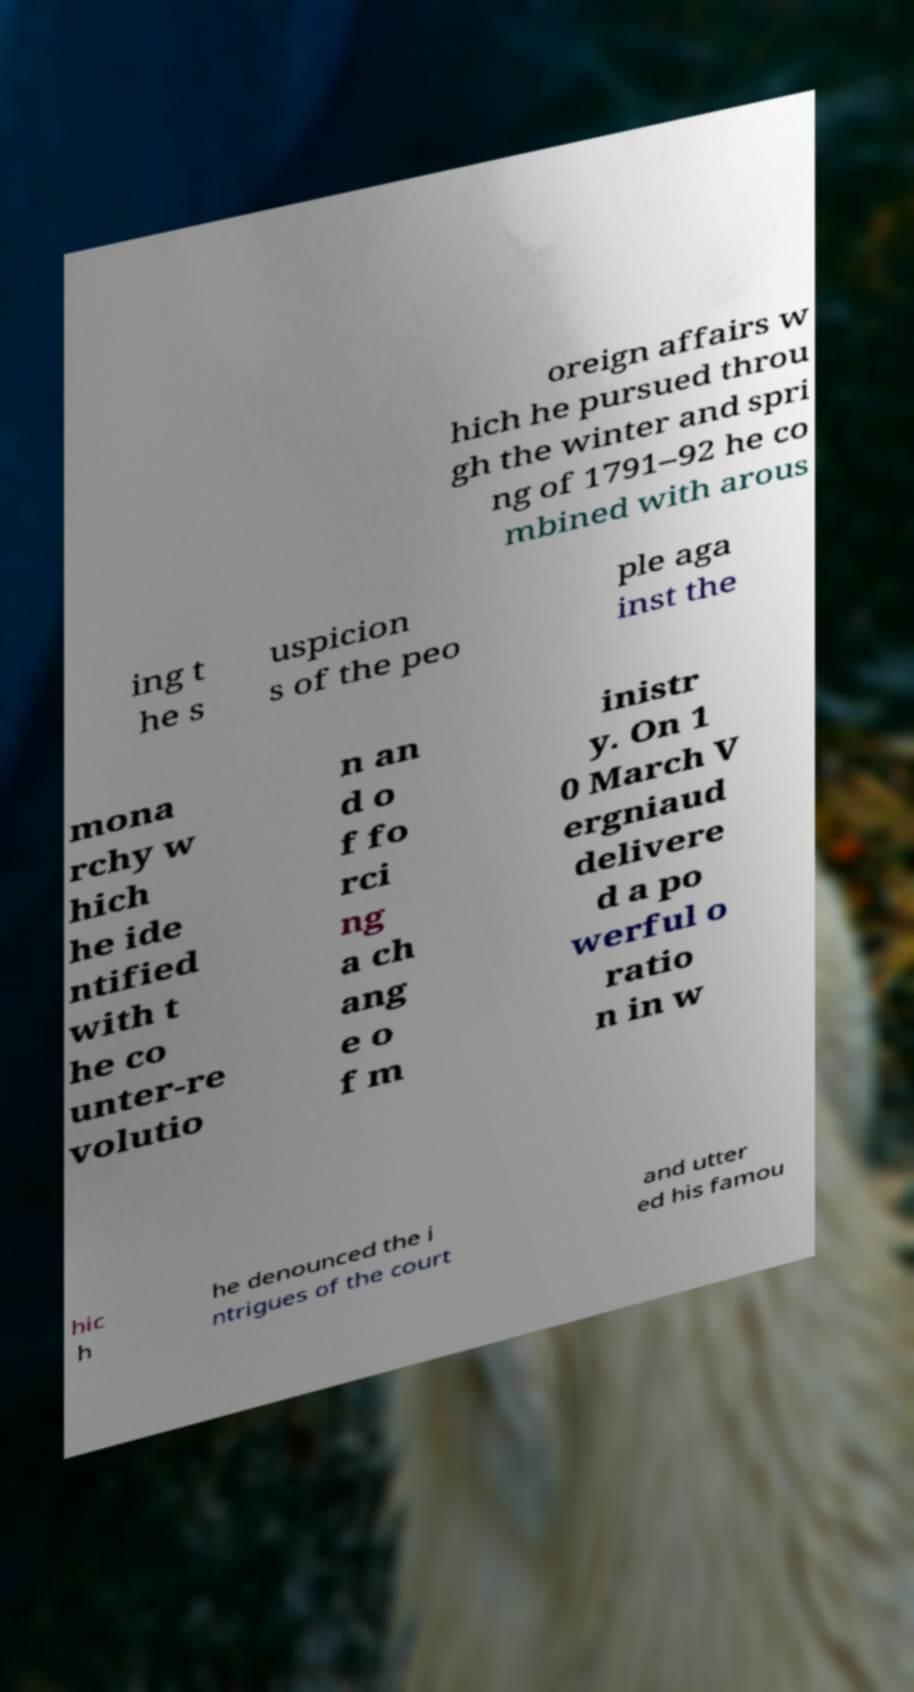For documentation purposes, I need the text within this image transcribed. Could you provide that? oreign affairs w hich he pursued throu gh the winter and spri ng of 1791–92 he co mbined with arous ing t he s uspicion s of the peo ple aga inst the mona rchy w hich he ide ntified with t he co unter-re volutio n an d o f fo rci ng a ch ang e o f m inistr y. On 1 0 March V ergniaud delivere d a po werful o ratio n in w hic h he denounced the i ntrigues of the court and utter ed his famou 